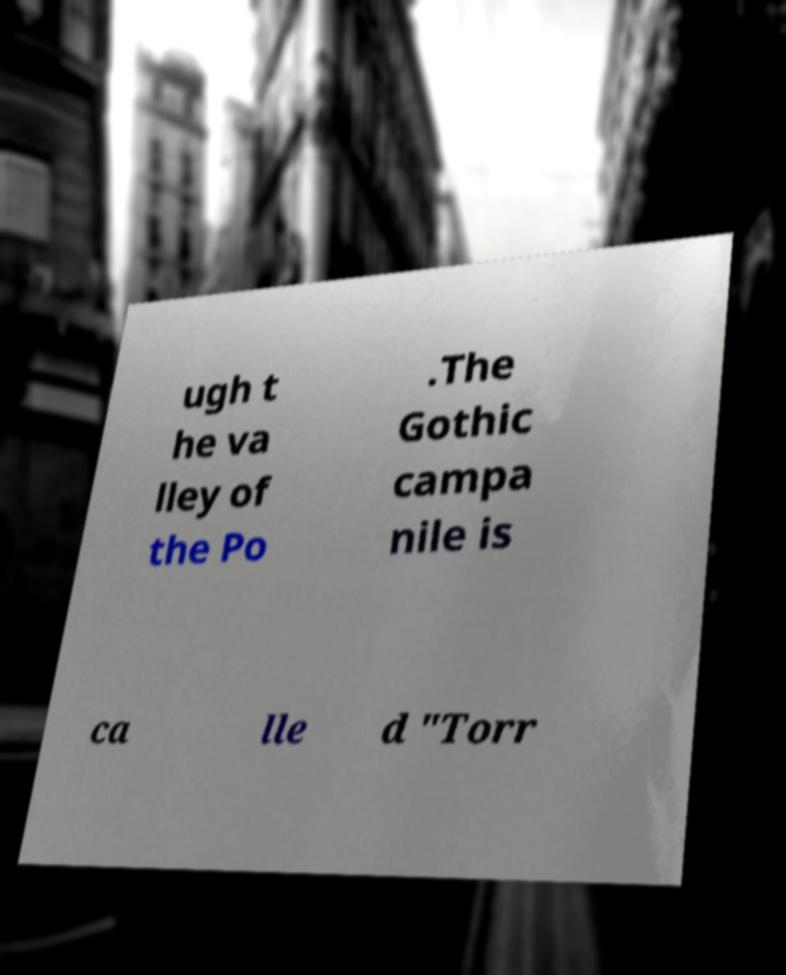Could you assist in decoding the text presented in this image and type it out clearly? ugh t he va lley of the Po .The Gothic campa nile is ca lle d "Torr 